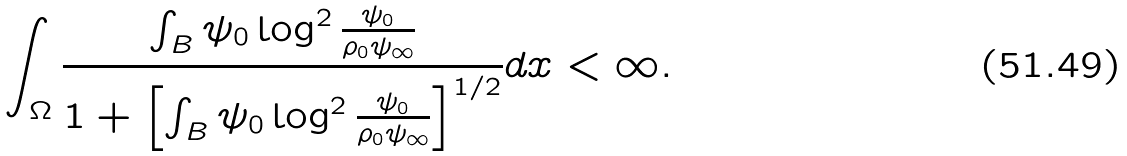Convert formula to latex. <formula><loc_0><loc_0><loc_500><loc_500>\int _ { \Omega } \frac { \int _ { B } \psi _ { 0 } \log ^ { 2 } \frac { \psi _ { 0 } } { \rho _ { 0 } \psi _ { \infty } } } { 1 + \left [ \int _ { B } \psi _ { 0 } \log ^ { 2 } \frac { \psi _ { 0 } } { \rho _ { 0 } \psi _ { \infty } } \right ] ^ { 1 / 2 } } d x < \infty .</formula> 